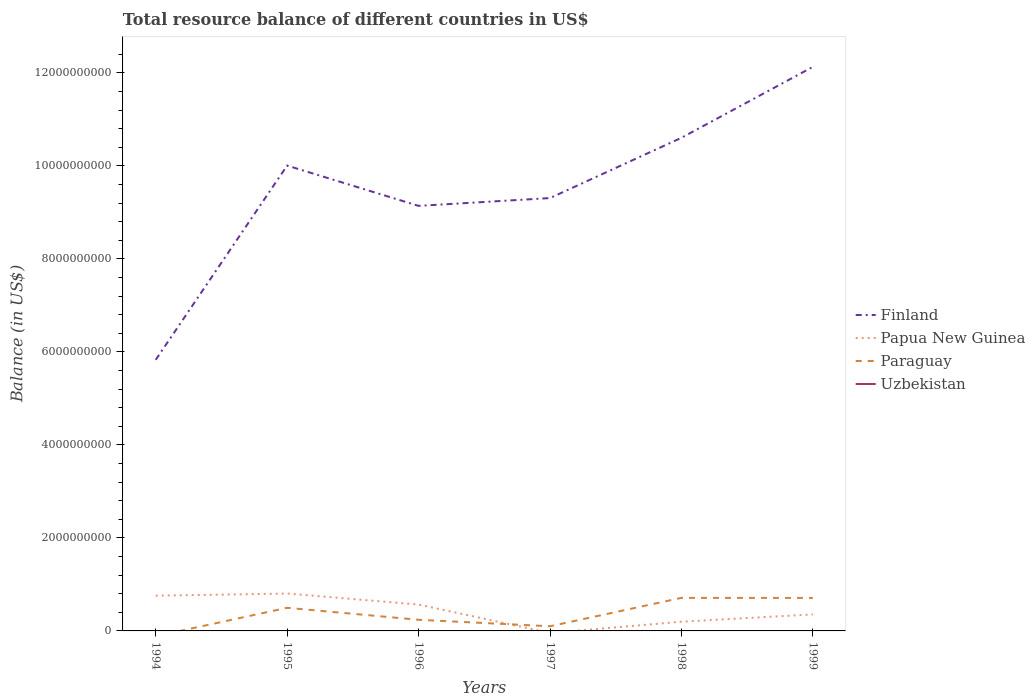How many different coloured lines are there?
Offer a very short reply. 3. Does the line corresponding to Paraguay intersect with the line corresponding to Finland?
Ensure brevity in your answer.  No. Is the number of lines equal to the number of legend labels?
Your answer should be very brief. No. Across all years, what is the maximum total resource balance in Papua New Guinea?
Your response must be concise. 0. What is the total total resource balance in Papua New Guinea in the graph?
Provide a short and direct response. 3.70e+08. What is the difference between the highest and the second highest total resource balance in Paraguay?
Your answer should be compact. 7.11e+08. What is the difference between the highest and the lowest total resource balance in Uzbekistan?
Offer a terse response. 0. Is the total resource balance in Uzbekistan strictly greater than the total resource balance in Finland over the years?
Give a very brief answer. Yes. How many lines are there?
Your answer should be compact. 3. How many years are there in the graph?
Your answer should be compact. 6. What is the difference between two consecutive major ticks on the Y-axis?
Provide a short and direct response. 2.00e+09. How are the legend labels stacked?
Provide a succinct answer. Vertical. What is the title of the graph?
Your answer should be very brief. Total resource balance of different countries in US$. Does "Nigeria" appear as one of the legend labels in the graph?
Make the answer very short. No. What is the label or title of the Y-axis?
Offer a terse response. Balance (in US$). What is the Balance (in US$) in Finland in 1994?
Offer a terse response. 5.83e+09. What is the Balance (in US$) in Papua New Guinea in 1994?
Your response must be concise. 7.58e+08. What is the Balance (in US$) in Uzbekistan in 1994?
Ensure brevity in your answer.  0. What is the Balance (in US$) in Finland in 1995?
Offer a terse response. 1.00e+1. What is the Balance (in US$) of Papua New Guinea in 1995?
Provide a succinct answer. 8.04e+08. What is the Balance (in US$) of Paraguay in 1995?
Ensure brevity in your answer.  4.97e+08. What is the Balance (in US$) of Uzbekistan in 1995?
Offer a terse response. 0. What is the Balance (in US$) of Finland in 1996?
Offer a terse response. 9.14e+09. What is the Balance (in US$) in Papua New Guinea in 1996?
Your answer should be compact. 5.67e+08. What is the Balance (in US$) in Paraguay in 1996?
Offer a terse response. 2.39e+08. What is the Balance (in US$) of Finland in 1997?
Provide a succinct answer. 9.31e+09. What is the Balance (in US$) in Papua New Guinea in 1997?
Keep it short and to the point. 0. What is the Balance (in US$) of Paraguay in 1997?
Your answer should be compact. 1.00e+08. What is the Balance (in US$) of Finland in 1998?
Ensure brevity in your answer.  1.06e+1. What is the Balance (in US$) of Papua New Guinea in 1998?
Ensure brevity in your answer.  1.98e+08. What is the Balance (in US$) in Paraguay in 1998?
Provide a succinct answer. 7.11e+08. What is the Balance (in US$) in Finland in 1999?
Your answer should be very brief. 1.21e+1. What is the Balance (in US$) in Papua New Guinea in 1999?
Offer a very short reply. 3.56e+08. What is the Balance (in US$) of Paraguay in 1999?
Keep it short and to the point. 7.09e+08. Across all years, what is the maximum Balance (in US$) in Finland?
Your answer should be compact. 1.21e+1. Across all years, what is the maximum Balance (in US$) in Papua New Guinea?
Make the answer very short. 8.04e+08. Across all years, what is the maximum Balance (in US$) of Paraguay?
Offer a very short reply. 7.11e+08. Across all years, what is the minimum Balance (in US$) in Finland?
Your answer should be very brief. 5.83e+09. What is the total Balance (in US$) of Finland in the graph?
Ensure brevity in your answer.  5.70e+1. What is the total Balance (in US$) of Papua New Guinea in the graph?
Your answer should be compact. 2.68e+09. What is the total Balance (in US$) of Paraguay in the graph?
Provide a succinct answer. 2.26e+09. What is the total Balance (in US$) of Uzbekistan in the graph?
Ensure brevity in your answer.  0. What is the difference between the Balance (in US$) in Finland in 1994 and that in 1995?
Your answer should be compact. -4.18e+09. What is the difference between the Balance (in US$) of Papua New Guinea in 1994 and that in 1995?
Your answer should be compact. -4.63e+07. What is the difference between the Balance (in US$) of Finland in 1994 and that in 1996?
Keep it short and to the point. -3.31e+09. What is the difference between the Balance (in US$) in Papua New Guinea in 1994 and that in 1996?
Your response must be concise. 1.90e+08. What is the difference between the Balance (in US$) in Finland in 1994 and that in 1997?
Provide a short and direct response. -3.48e+09. What is the difference between the Balance (in US$) of Finland in 1994 and that in 1998?
Offer a very short reply. -4.77e+09. What is the difference between the Balance (in US$) of Papua New Guinea in 1994 and that in 1998?
Give a very brief answer. 5.60e+08. What is the difference between the Balance (in US$) in Finland in 1994 and that in 1999?
Your answer should be very brief. -6.30e+09. What is the difference between the Balance (in US$) in Papua New Guinea in 1994 and that in 1999?
Ensure brevity in your answer.  4.02e+08. What is the difference between the Balance (in US$) of Finland in 1995 and that in 1996?
Your answer should be very brief. 8.66e+08. What is the difference between the Balance (in US$) in Papua New Guinea in 1995 and that in 1996?
Offer a very short reply. 2.36e+08. What is the difference between the Balance (in US$) of Paraguay in 1995 and that in 1996?
Provide a short and direct response. 2.58e+08. What is the difference between the Balance (in US$) in Finland in 1995 and that in 1997?
Make the answer very short. 6.98e+08. What is the difference between the Balance (in US$) of Paraguay in 1995 and that in 1997?
Give a very brief answer. 3.97e+08. What is the difference between the Balance (in US$) in Finland in 1995 and that in 1998?
Provide a short and direct response. -5.98e+08. What is the difference between the Balance (in US$) of Papua New Guinea in 1995 and that in 1998?
Give a very brief answer. 6.06e+08. What is the difference between the Balance (in US$) in Paraguay in 1995 and that in 1998?
Offer a very short reply. -2.13e+08. What is the difference between the Balance (in US$) of Finland in 1995 and that in 1999?
Ensure brevity in your answer.  -2.12e+09. What is the difference between the Balance (in US$) of Papua New Guinea in 1995 and that in 1999?
Ensure brevity in your answer.  4.48e+08. What is the difference between the Balance (in US$) in Paraguay in 1995 and that in 1999?
Your answer should be very brief. -2.12e+08. What is the difference between the Balance (in US$) of Finland in 1996 and that in 1997?
Your answer should be compact. -1.68e+08. What is the difference between the Balance (in US$) of Paraguay in 1996 and that in 1997?
Provide a short and direct response. 1.39e+08. What is the difference between the Balance (in US$) in Finland in 1996 and that in 1998?
Your answer should be compact. -1.46e+09. What is the difference between the Balance (in US$) of Papua New Guinea in 1996 and that in 1998?
Your response must be concise. 3.70e+08. What is the difference between the Balance (in US$) in Paraguay in 1996 and that in 1998?
Keep it short and to the point. -4.71e+08. What is the difference between the Balance (in US$) of Finland in 1996 and that in 1999?
Your response must be concise. -2.99e+09. What is the difference between the Balance (in US$) in Papua New Guinea in 1996 and that in 1999?
Your response must be concise. 2.12e+08. What is the difference between the Balance (in US$) of Paraguay in 1996 and that in 1999?
Your response must be concise. -4.70e+08. What is the difference between the Balance (in US$) of Finland in 1997 and that in 1998?
Your answer should be compact. -1.30e+09. What is the difference between the Balance (in US$) in Paraguay in 1997 and that in 1998?
Offer a very short reply. -6.10e+08. What is the difference between the Balance (in US$) of Finland in 1997 and that in 1999?
Your answer should be very brief. -2.82e+09. What is the difference between the Balance (in US$) in Paraguay in 1997 and that in 1999?
Provide a succinct answer. -6.09e+08. What is the difference between the Balance (in US$) of Finland in 1998 and that in 1999?
Provide a short and direct response. -1.52e+09. What is the difference between the Balance (in US$) in Papua New Guinea in 1998 and that in 1999?
Offer a terse response. -1.58e+08. What is the difference between the Balance (in US$) of Paraguay in 1998 and that in 1999?
Your response must be concise. 1.38e+06. What is the difference between the Balance (in US$) of Finland in 1994 and the Balance (in US$) of Papua New Guinea in 1995?
Provide a succinct answer. 5.03e+09. What is the difference between the Balance (in US$) in Finland in 1994 and the Balance (in US$) in Paraguay in 1995?
Your answer should be compact. 5.33e+09. What is the difference between the Balance (in US$) of Papua New Guinea in 1994 and the Balance (in US$) of Paraguay in 1995?
Provide a succinct answer. 2.60e+08. What is the difference between the Balance (in US$) of Finland in 1994 and the Balance (in US$) of Papua New Guinea in 1996?
Provide a succinct answer. 5.26e+09. What is the difference between the Balance (in US$) of Finland in 1994 and the Balance (in US$) of Paraguay in 1996?
Provide a short and direct response. 5.59e+09. What is the difference between the Balance (in US$) of Papua New Guinea in 1994 and the Balance (in US$) of Paraguay in 1996?
Make the answer very short. 5.18e+08. What is the difference between the Balance (in US$) in Finland in 1994 and the Balance (in US$) in Paraguay in 1997?
Provide a short and direct response. 5.73e+09. What is the difference between the Balance (in US$) of Papua New Guinea in 1994 and the Balance (in US$) of Paraguay in 1997?
Keep it short and to the point. 6.57e+08. What is the difference between the Balance (in US$) of Finland in 1994 and the Balance (in US$) of Papua New Guinea in 1998?
Ensure brevity in your answer.  5.63e+09. What is the difference between the Balance (in US$) in Finland in 1994 and the Balance (in US$) in Paraguay in 1998?
Keep it short and to the point. 5.12e+09. What is the difference between the Balance (in US$) of Papua New Guinea in 1994 and the Balance (in US$) of Paraguay in 1998?
Your answer should be compact. 4.69e+07. What is the difference between the Balance (in US$) of Finland in 1994 and the Balance (in US$) of Papua New Guinea in 1999?
Keep it short and to the point. 5.47e+09. What is the difference between the Balance (in US$) in Finland in 1994 and the Balance (in US$) in Paraguay in 1999?
Provide a short and direct response. 5.12e+09. What is the difference between the Balance (in US$) in Papua New Guinea in 1994 and the Balance (in US$) in Paraguay in 1999?
Ensure brevity in your answer.  4.83e+07. What is the difference between the Balance (in US$) in Finland in 1995 and the Balance (in US$) in Papua New Guinea in 1996?
Your answer should be compact. 9.44e+09. What is the difference between the Balance (in US$) of Finland in 1995 and the Balance (in US$) of Paraguay in 1996?
Make the answer very short. 9.77e+09. What is the difference between the Balance (in US$) in Papua New Guinea in 1995 and the Balance (in US$) in Paraguay in 1996?
Make the answer very short. 5.64e+08. What is the difference between the Balance (in US$) of Finland in 1995 and the Balance (in US$) of Paraguay in 1997?
Offer a very short reply. 9.91e+09. What is the difference between the Balance (in US$) of Papua New Guinea in 1995 and the Balance (in US$) of Paraguay in 1997?
Ensure brevity in your answer.  7.04e+08. What is the difference between the Balance (in US$) in Finland in 1995 and the Balance (in US$) in Papua New Guinea in 1998?
Provide a short and direct response. 9.81e+09. What is the difference between the Balance (in US$) in Finland in 1995 and the Balance (in US$) in Paraguay in 1998?
Offer a terse response. 9.29e+09. What is the difference between the Balance (in US$) of Papua New Guinea in 1995 and the Balance (in US$) of Paraguay in 1998?
Provide a short and direct response. 9.32e+07. What is the difference between the Balance (in US$) in Finland in 1995 and the Balance (in US$) in Papua New Guinea in 1999?
Ensure brevity in your answer.  9.65e+09. What is the difference between the Balance (in US$) in Finland in 1995 and the Balance (in US$) in Paraguay in 1999?
Give a very brief answer. 9.30e+09. What is the difference between the Balance (in US$) of Papua New Guinea in 1995 and the Balance (in US$) of Paraguay in 1999?
Ensure brevity in your answer.  9.46e+07. What is the difference between the Balance (in US$) in Finland in 1996 and the Balance (in US$) in Paraguay in 1997?
Make the answer very short. 9.04e+09. What is the difference between the Balance (in US$) of Papua New Guinea in 1996 and the Balance (in US$) of Paraguay in 1997?
Make the answer very short. 4.67e+08. What is the difference between the Balance (in US$) in Finland in 1996 and the Balance (in US$) in Papua New Guinea in 1998?
Provide a succinct answer. 8.94e+09. What is the difference between the Balance (in US$) in Finland in 1996 and the Balance (in US$) in Paraguay in 1998?
Your response must be concise. 8.43e+09. What is the difference between the Balance (in US$) of Papua New Guinea in 1996 and the Balance (in US$) of Paraguay in 1998?
Give a very brief answer. -1.43e+08. What is the difference between the Balance (in US$) in Finland in 1996 and the Balance (in US$) in Papua New Guinea in 1999?
Your response must be concise. 8.78e+09. What is the difference between the Balance (in US$) in Finland in 1996 and the Balance (in US$) in Paraguay in 1999?
Your answer should be very brief. 8.43e+09. What is the difference between the Balance (in US$) of Papua New Guinea in 1996 and the Balance (in US$) of Paraguay in 1999?
Offer a terse response. -1.42e+08. What is the difference between the Balance (in US$) in Finland in 1997 and the Balance (in US$) in Papua New Guinea in 1998?
Your answer should be very brief. 9.11e+09. What is the difference between the Balance (in US$) in Finland in 1997 and the Balance (in US$) in Paraguay in 1998?
Provide a short and direct response. 8.60e+09. What is the difference between the Balance (in US$) in Finland in 1997 and the Balance (in US$) in Papua New Guinea in 1999?
Your answer should be very brief. 8.95e+09. What is the difference between the Balance (in US$) in Finland in 1997 and the Balance (in US$) in Paraguay in 1999?
Your response must be concise. 8.60e+09. What is the difference between the Balance (in US$) in Finland in 1998 and the Balance (in US$) in Papua New Guinea in 1999?
Your response must be concise. 1.02e+1. What is the difference between the Balance (in US$) in Finland in 1998 and the Balance (in US$) in Paraguay in 1999?
Your answer should be compact. 9.89e+09. What is the difference between the Balance (in US$) in Papua New Guinea in 1998 and the Balance (in US$) in Paraguay in 1999?
Ensure brevity in your answer.  -5.11e+08. What is the average Balance (in US$) in Finland per year?
Give a very brief answer. 9.50e+09. What is the average Balance (in US$) of Papua New Guinea per year?
Ensure brevity in your answer.  4.47e+08. What is the average Balance (in US$) of Paraguay per year?
Make the answer very short. 3.76e+08. In the year 1994, what is the difference between the Balance (in US$) of Finland and Balance (in US$) of Papua New Guinea?
Offer a very short reply. 5.07e+09. In the year 1995, what is the difference between the Balance (in US$) in Finland and Balance (in US$) in Papua New Guinea?
Give a very brief answer. 9.20e+09. In the year 1995, what is the difference between the Balance (in US$) of Finland and Balance (in US$) of Paraguay?
Offer a terse response. 9.51e+09. In the year 1995, what is the difference between the Balance (in US$) of Papua New Guinea and Balance (in US$) of Paraguay?
Offer a very short reply. 3.07e+08. In the year 1996, what is the difference between the Balance (in US$) in Finland and Balance (in US$) in Papua New Guinea?
Provide a short and direct response. 8.57e+09. In the year 1996, what is the difference between the Balance (in US$) of Finland and Balance (in US$) of Paraguay?
Give a very brief answer. 8.90e+09. In the year 1996, what is the difference between the Balance (in US$) in Papua New Guinea and Balance (in US$) in Paraguay?
Your answer should be compact. 3.28e+08. In the year 1997, what is the difference between the Balance (in US$) in Finland and Balance (in US$) in Paraguay?
Provide a short and direct response. 9.21e+09. In the year 1998, what is the difference between the Balance (in US$) in Finland and Balance (in US$) in Papua New Guinea?
Make the answer very short. 1.04e+1. In the year 1998, what is the difference between the Balance (in US$) of Finland and Balance (in US$) of Paraguay?
Make the answer very short. 9.89e+09. In the year 1998, what is the difference between the Balance (in US$) in Papua New Guinea and Balance (in US$) in Paraguay?
Offer a terse response. -5.13e+08. In the year 1999, what is the difference between the Balance (in US$) of Finland and Balance (in US$) of Papua New Guinea?
Provide a succinct answer. 1.18e+1. In the year 1999, what is the difference between the Balance (in US$) in Finland and Balance (in US$) in Paraguay?
Provide a succinct answer. 1.14e+1. In the year 1999, what is the difference between the Balance (in US$) of Papua New Guinea and Balance (in US$) of Paraguay?
Offer a very short reply. -3.54e+08. What is the ratio of the Balance (in US$) of Finland in 1994 to that in 1995?
Your response must be concise. 0.58. What is the ratio of the Balance (in US$) in Papua New Guinea in 1994 to that in 1995?
Your answer should be compact. 0.94. What is the ratio of the Balance (in US$) in Finland in 1994 to that in 1996?
Your answer should be compact. 0.64. What is the ratio of the Balance (in US$) of Papua New Guinea in 1994 to that in 1996?
Give a very brief answer. 1.34. What is the ratio of the Balance (in US$) in Finland in 1994 to that in 1997?
Your answer should be very brief. 0.63. What is the ratio of the Balance (in US$) of Finland in 1994 to that in 1998?
Your answer should be very brief. 0.55. What is the ratio of the Balance (in US$) in Papua New Guinea in 1994 to that in 1998?
Provide a short and direct response. 3.83. What is the ratio of the Balance (in US$) of Finland in 1994 to that in 1999?
Your answer should be very brief. 0.48. What is the ratio of the Balance (in US$) of Papua New Guinea in 1994 to that in 1999?
Your answer should be very brief. 2.13. What is the ratio of the Balance (in US$) of Finland in 1995 to that in 1996?
Ensure brevity in your answer.  1.09. What is the ratio of the Balance (in US$) in Papua New Guinea in 1995 to that in 1996?
Your response must be concise. 1.42. What is the ratio of the Balance (in US$) in Paraguay in 1995 to that in 1996?
Ensure brevity in your answer.  2.08. What is the ratio of the Balance (in US$) of Finland in 1995 to that in 1997?
Keep it short and to the point. 1.07. What is the ratio of the Balance (in US$) in Paraguay in 1995 to that in 1997?
Offer a very short reply. 4.96. What is the ratio of the Balance (in US$) of Finland in 1995 to that in 1998?
Your answer should be very brief. 0.94. What is the ratio of the Balance (in US$) in Papua New Guinea in 1995 to that in 1998?
Provide a succinct answer. 4.06. What is the ratio of the Balance (in US$) of Paraguay in 1995 to that in 1998?
Your answer should be very brief. 0.7. What is the ratio of the Balance (in US$) of Finland in 1995 to that in 1999?
Make the answer very short. 0.82. What is the ratio of the Balance (in US$) in Papua New Guinea in 1995 to that in 1999?
Ensure brevity in your answer.  2.26. What is the ratio of the Balance (in US$) in Paraguay in 1995 to that in 1999?
Offer a terse response. 0.7. What is the ratio of the Balance (in US$) of Finland in 1996 to that in 1997?
Offer a very short reply. 0.98. What is the ratio of the Balance (in US$) of Paraguay in 1996 to that in 1997?
Offer a very short reply. 2.39. What is the ratio of the Balance (in US$) of Finland in 1996 to that in 1998?
Your answer should be very brief. 0.86. What is the ratio of the Balance (in US$) of Papua New Guinea in 1996 to that in 1998?
Offer a terse response. 2.87. What is the ratio of the Balance (in US$) in Paraguay in 1996 to that in 1998?
Provide a succinct answer. 0.34. What is the ratio of the Balance (in US$) in Finland in 1996 to that in 1999?
Your response must be concise. 0.75. What is the ratio of the Balance (in US$) in Papua New Guinea in 1996 to that in 1999?
Your answer should be very brief. 1.6. What is the ratio of the Balance (in US$) of Paraguay in 1996 to that in 1999?
Give a very brief answer. 0.34. What is the ratio of the Balance (in US$) in Finland in 1997 to that in 1998?
Your response must be concise. 0.88. What is the ratio of the Balance (in US$) in Paraguay in 1997 to that in 1998?
Ensure brevity in your answer.  0.14. What is the ratio of the Balance (in US$) in Finland in 1997 to that in 1999?
Offer a terse response. 0.77. What is the ratio of the Balance (in US$) of Paraguay in 1997 to that in 1999?
Ensure brevity in your answer.  0.14. What is the ratio of the Balance (in US$) of Finland in 1998 to that in 1999?
Give a very brief answer. 0.87. What is the ratio of the Balance (in US$) of Papua New Guinea in 1998 to that in 1999?
Keep it short and to the point. 0.56. What is the difference between the highest and the second highest Balance (in US$) of Finland?
Make the answer very short. 1.52e+09. What is the difference between the highest and the second highest Balance (in US$) of Papua New Guinea?
Make the answer very short. 4.63e+07. What is the difference between the highest and the second highest Balance (in US$) of Paraguay?
Offer a very short reply. 1.38e+06. What is the difference between the highest and the lowest Balance (in US$) of Finland?
Make the answer very short. 6.30e+09. What is the difference between the highest and the lowest Balance (in US$) of Papua New Guinea?
Your response must be concise. 8.04e+08. What is the difference between the highest and the lowest Balance (in US$) in Paraguay?
Provide a succinct answer. 7.11e+08. 